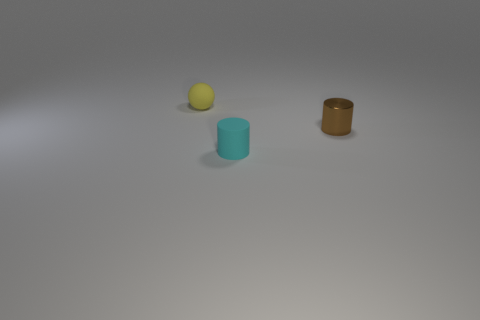Is there anything else that has the same material as the small brown thing?
Offer a terse response. No. There is a small rubber object that is in front of the yellow rubber object; are there any small things that are right of it?
Your answer should be compact. Yes. What color is the other object that is the same shape as the cyan rubber object?
Your response must be concise. Brown. There is a small thing on the right side of the small cyan object; is its color the same as the matte cylinder?
Offer a very short reply. No. What number of things are either rubber things that are left of the cyan cylinder or tiny yellow balls?
Your answer should be very brief. 1. What material is the tiny object that is in front of the tiny cylinder to the right of the small rubber object that is in front of the small rubber ball made of?
Give a very brief answer. Rubber. Are there more tiny yellow matte spheres in front of the tiny yellow sphere than small cylinders that are in front of the tiny brown metal cylinder?
Provide a short and direct response. No. How many cylinders are either purple things or small brown shiny objects?
Offer a terse response. 1. There is a object on the right side of the matte thing that is right of the ball; what number of brown cylinders are on the right side of it?
Ensure brevity in your answer.  0. Are there more yellow objects than cylinders?
Your answer should be very brief. No. 